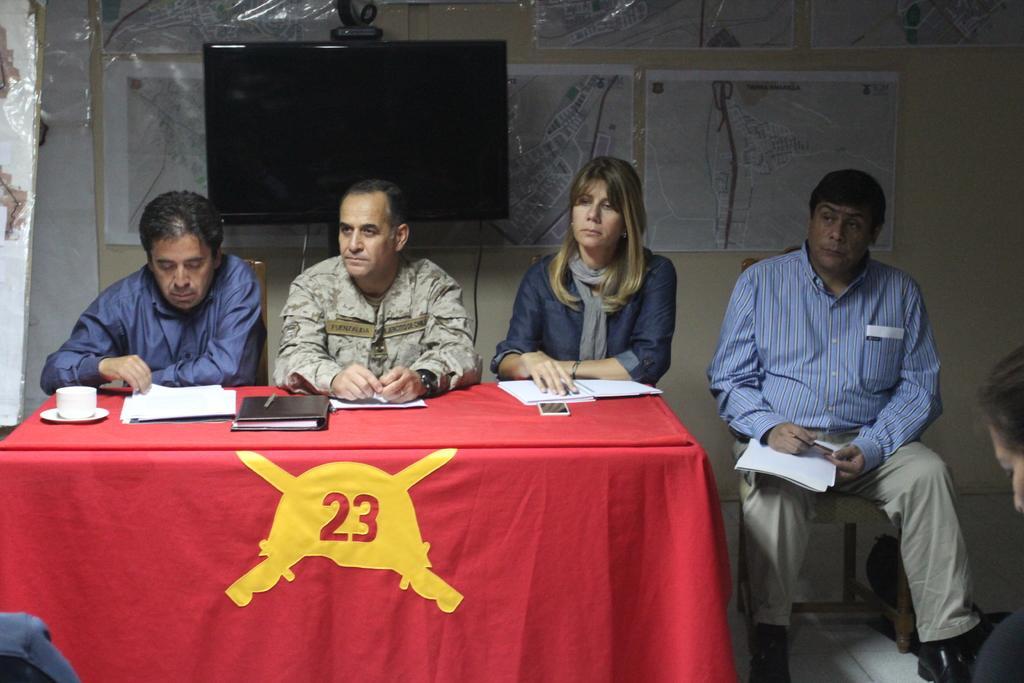In one or two sentences, can you explain what this image depicts? This picture is of inside. On the right there is a man wearing blue color shirt, holding a pencil and sitting on chair, beside him there is a woman sitting on the chair. In the center there are two persons sitting on the chair, in front of them there is a table covered with a red cloth and on the top of the table there is a mobile phone, a book, a cup with a saucer and some papers are placed. In the background we can see a wall, some posters hanging on the wall and a wall mounted television. 